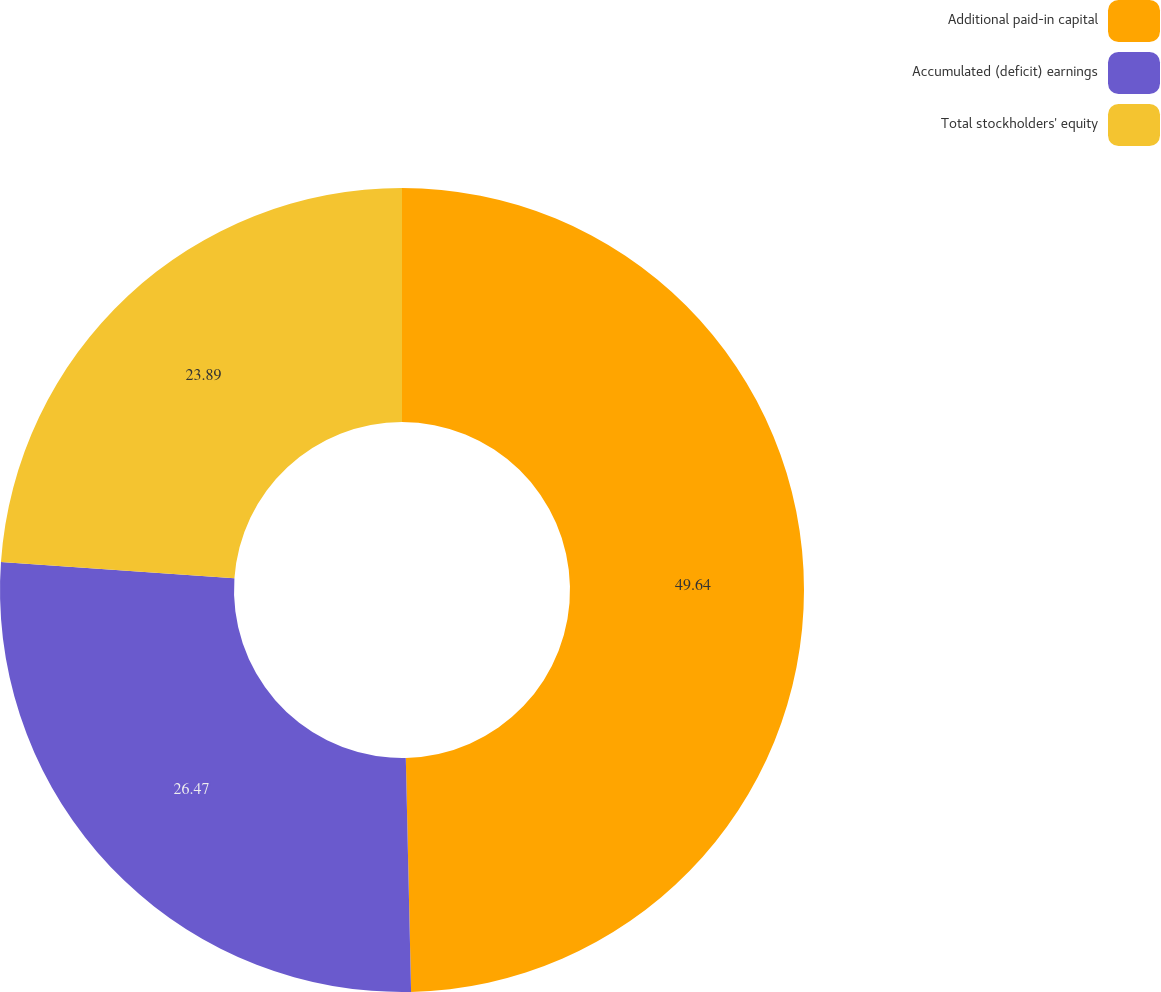Convert chart. <chart><loc_0><loc_0><loc_500><loc_500><pie_chart><fcel>Additional paid-in capital<fcel>Accumulated (deficit) earnings<fcel>Total stockholders' equity<nl><fcel>49.64%<fcel>26.47%<fcel>23.89%<nl></chart> 